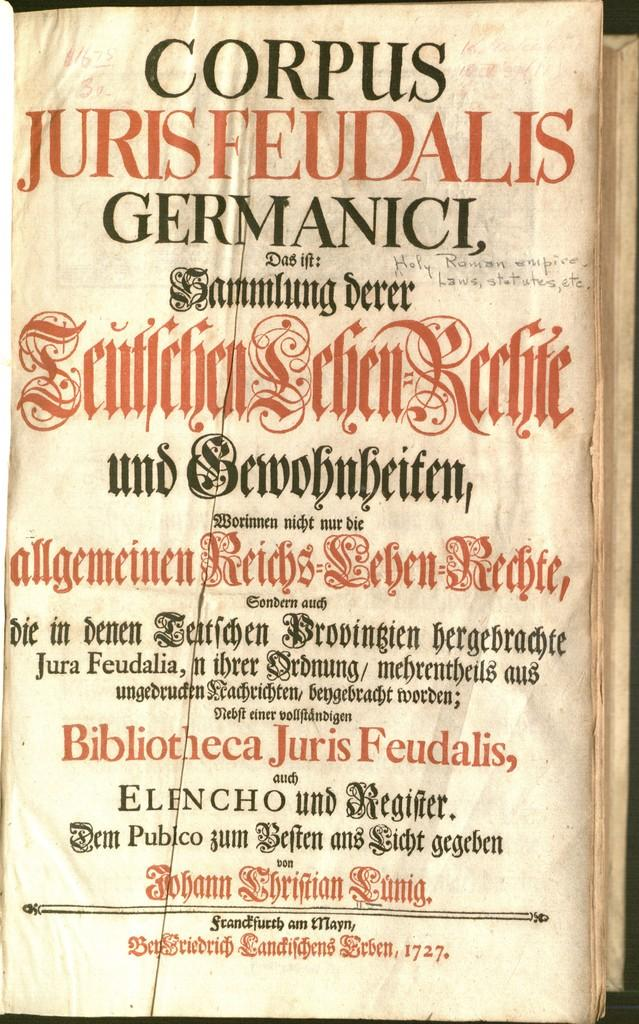<image>
Share a concise interpretation of the image provided. Book that says "Corpus Jurisfeudalis" on top and the year 1727 on the bottom. 